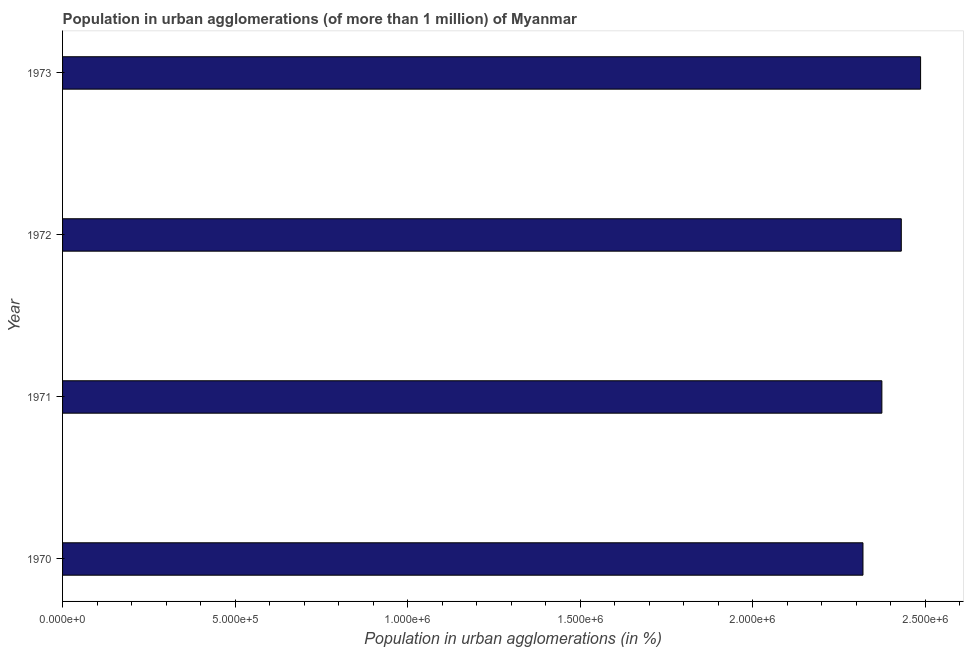What is the title of the graph?
Provide a succinct answer. Population in urban agglomerations (of more than 1 million) of Myanmar. What is the label or title of the X-axis?
Your answer should be compact. Population in urban agglomerations (in %). What is the label or title of the Y-axis?
Provide a short and direct response. Year. What is the population in urban agglomerations in 1970?
Ensure brevity in your answer.  2.32e+06. Across all years, what is the maximum population in urban agglomerations?
Your response must be concise. 2.49e+06. Across all years, what is the minimum population in urban agglomerations?
Offer a very short reply. 2.32e+06. In which year was the population in urban agglomerations maximum?
Provide a succinct answer. 1973. In which year was the population in urban agglomerations minimum?
Offer a very short reply. 1970. What is the sum of the population in urban agglomerations?
Your answer should be very brief. 9.61e+06. What is the difference between the population in urban agglomerations in 1970 and 1971?
Your answer should be compact. -5.48e+04. What is the average population in urban agglomerations per year?
Your response must be concise. 2.40e+06. What is the median population in urban agglomerations?
Your response must be concise. 2.40e+06. In how many years, is the population in urban agglomerations greater than 2000000 %?
Offer a very short reply. 4. What is the ratio of the population in urban agglomerations in 1970 to that in 1972?
Your answer should be very brief. 0.95. Is the population in urban agglomerations in 1970 less than that in 1972?
Offer a terse response. Yes. Is the difference between the population in urban agglomerations in 1971 and 1973 greater than the difference between any two years?
Keep it short and to the point. No. What is the difference between the highest and the second highest population in urban agglomerations?
Your response must be concise. 5.59e+04. What is the difference between the highest and the lowest population in urban agglomerations?
Your answer should be very brief. 1.67e+05. In how many years, is the population in urban agglomerations greater than the average population in urban agglomerations taken over all years?
Your answer should be compact. 2. How many bars are there?
Ensure brevity in your answer.  4. How many years are there in the graph?
Your answer should be compact. 4. Are the values on the major ticks of X-axis written in scientific E-notation?
Give a very brief answer. Yes. What is the Population in urban agglomerations (in %) in 1970?
Your answer should be very brief. 2.32e+06. What is the Population in urban agglomerations (in %) in 1971?
Offer a very short reply. 2.37e+06. What is the Population in urban agglomerations (in %) in 1972?
Make the answer very short. 2.43e+06. What is the Population in urban agglomerations (in %) of 1973?
Your answer should be very brief. 2.49e+06. What is the difference between the Population in urban agglomerations (in %) in 1970 and 1971?
Provide a succinct answer. -5.48e+04. What is the difference between the Population in urban agglomerations (in %) in 1970 and 1972?
Make the answer very short. -1.11e+05. What is the difference between the Population in urban agglomerations (in %) in 1970 and 1973?
Give a very brief answer. -1.67e+05. What is the difference between the Population in urban agglomerations (in %) in 1971 and 1972?
Give a very brief answer. -5.63e+04. What is the difference between the Population in urban agglomerations (in %) in 1971 and 1973?
Make the answer very short. -1.12e+05. What is the difference between the Population in urban agglomerations (in %) in 1972 and 1973?
Ensure brevity in your answer.  -5.59e+04. What is the ratio of the Population in urban agglomerations (in %) in 1970 to that in 1972?
Ensure brevity in your answer.  0.95. What is the ratio of the Population in urban agglomerations (in %) in 1970 to that in 1973?
Your answer should be very brief. 0.93. What is the ratio of the Population in urban agglomerations (in %) in 1971 to that in 1972?
Your answer should be very brief. 0.98. What is the ratio of the Population in urban agglomerations (in %) in 1971 to that in 1973?
Your answer should be very brief. 0.95. 